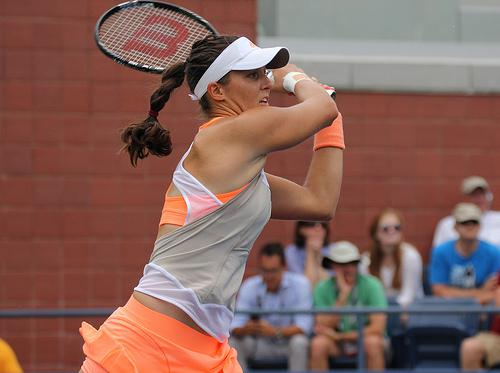Question: where is the picture taken?
Choices:
A. At a concert.
B. At a tennis court.
C. Baseball game.
D. Skating rink.
Answer with the letter. Answer: B Question: why is the woman lifting the racket?
Choices:
A. To serve.
B. To practice.
C. To return a ball.
D. To give to coach.
Answer with the letter. Answer: C Question: when was the picture taken?
Choices:
A. After a match.
B. During a tennis game.
C. Half-time.
D. Before the game.
Answer with the letter. Answer: B Question: how many tennis players are shown?
Choices:
A. One.
B. Two.
C. Four.
D. Zero.
Answer with the letter. Answer: A Question: what letter is on the racket?
Choices:
A. R.
B. B.
C. W.
D. K.
Answer with the letter. Answer: C Question: who is behind the player?
Choices:
A. The audience.
B. Another player.
C. Coach.
D. Mom.
Answer with the letter. Answer: A 